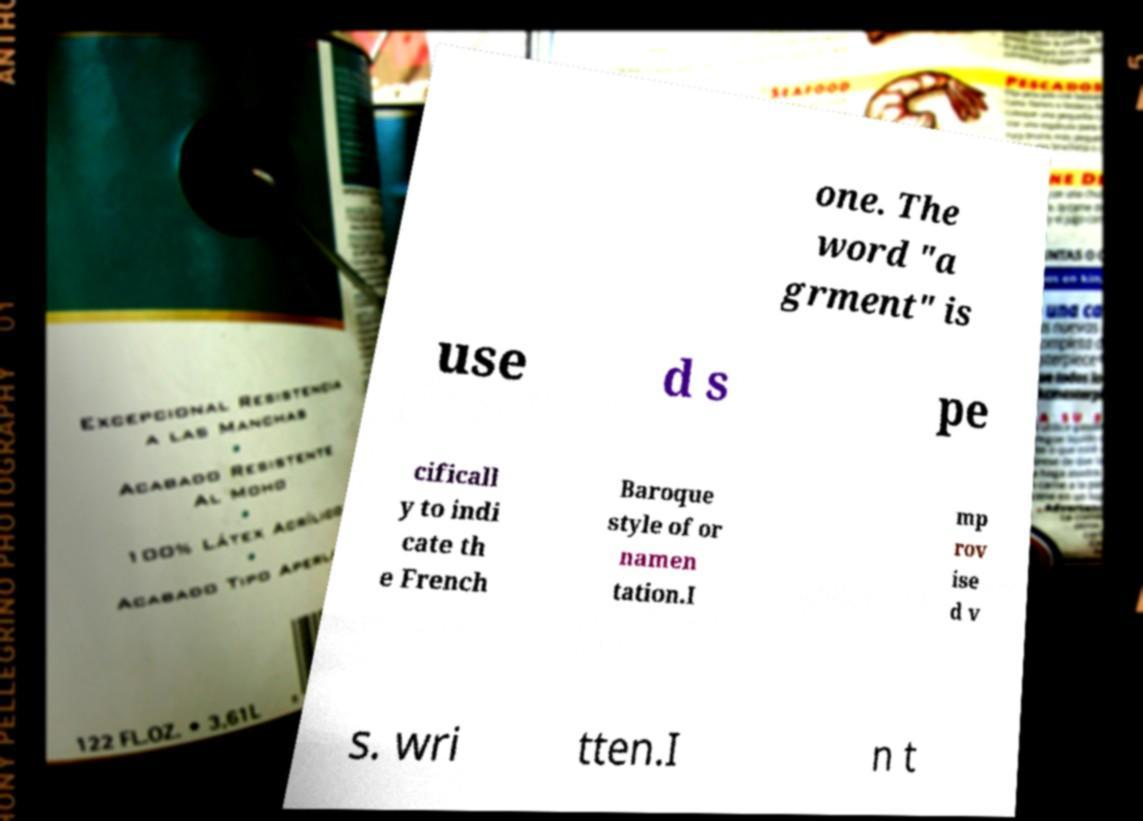Can you read and provide the text displayed in the image?This photo seems to have some interesting text. Can you extract and type it out for me? one. The word "a grment" is use d s pe cificall y to indi cate th e French Baroque style of or namen tation.I mp rov ise d v s. wri tten.I n t 